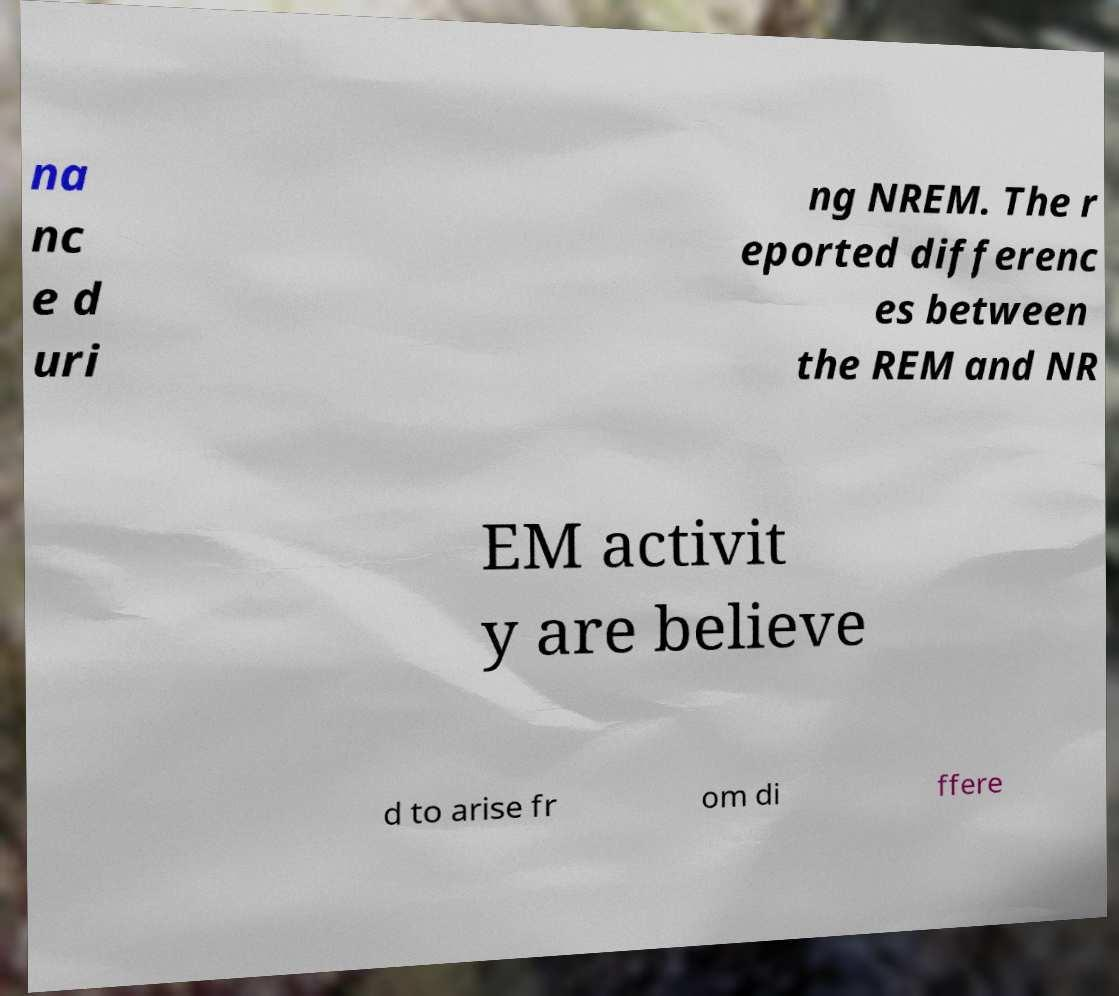Could you assist in decoding the text presented in this image and type it out clearly? na nc e d uri ng NREM. The r eported differenc es between the REM and NR EM activit y are believe d to arise fr om di ffere 